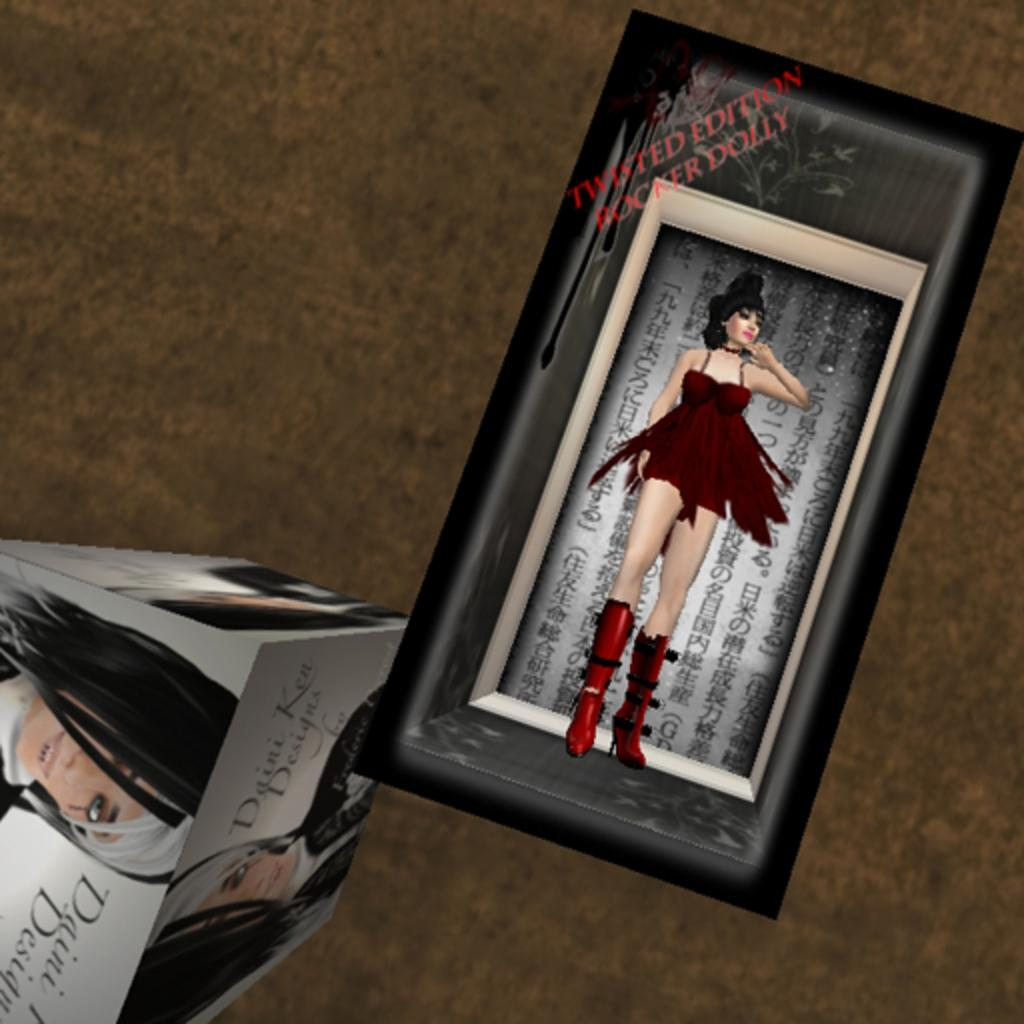What type of image is being described? The image is animated. Where is a specific object located in the image? There is a frame towards the right side of the image. What is depicted in the frame? A woman's picture is present in the frame. What can be seen on the left side of the image? There is a box on the left side of the image. Is there a snail crawling on the frame in the image? No, there is no snail present in the image. What type of cord is connected to the box in the image? There is no cord connected to the box in the image. 